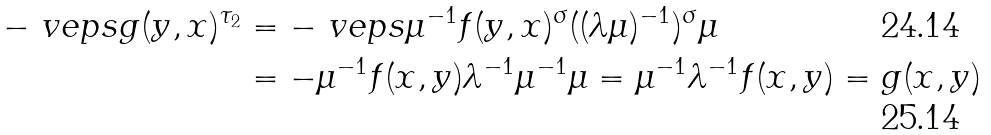Convert formula to latex. <formula><loc_0><loc_0><loc_500><loc_500>- \ v e p s g ( y , x ) ^ { \tau _ { 2 } } & = - \ v e p s \mu ^ { - 1 } f ( y , x ) ^ { \sigma } ( ( \lambda \mu ) ^ { - 1 } ) ^ { \sigma } \mu \\ & = - \mu ^ { - 1 } f ( x , y ) \lambda ^ { - 1 } \mu ^ { - 1 } \mu = \mu ^ { - 1 } \lambda ^ { - 1 } f ( x , y ) = g ( x , y )</formula> 